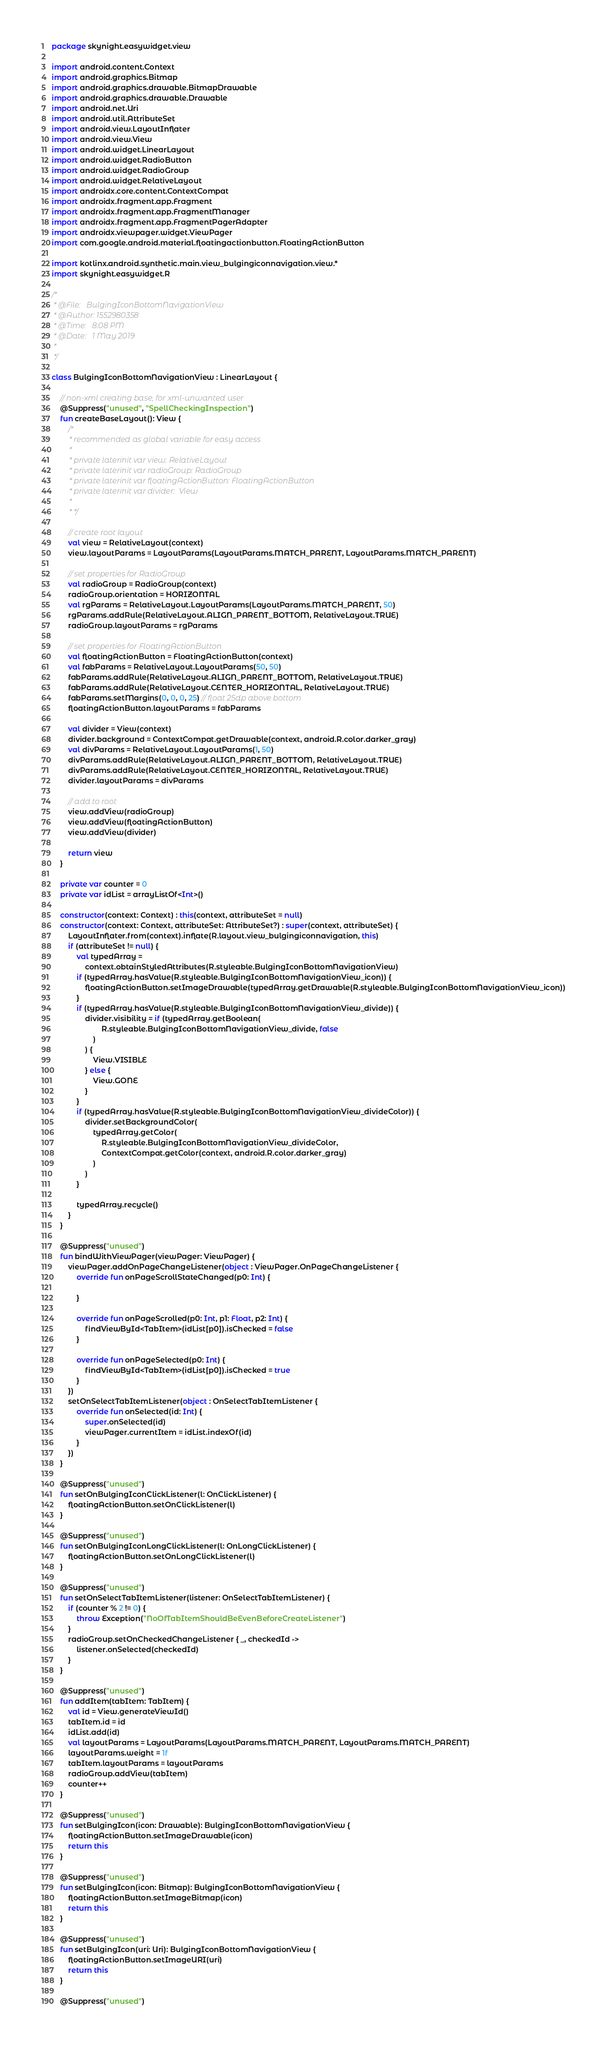Convert code to text. <code><loc_0><loc_0><loc_500><loc_500><_Kotlin_>package skynight.easywidget.view

import android.content.Context
import android.graphics.Bitmap
import android.graphics.drawable.BitmapDrawable
import android.graphics.drawable.Drawable
import android.net.Uri
import android.util.AttributeSet
import android.view.LayoutInflater
import android.view.View
import android.widget.LinearLayout
import android.widget.RadioButton
import android.widget.RadioGroup
import android.widget.RelativeLayout
import androidx.core.content.ContextCompat
import androidx.fragment.app.Fragment
import androidx.fragment.app.FragmentManager
import androidx.fragment.app.FragmentPagerAdapter
import androidx.viewpager.widget.ViewPager
import com.google.android.material.floatingactionbutton.FloatingActionButton

import kotlinx.android.synthetic.main.view_bulgingiconnavigation.view.*
import skynight.easywidget.R

/*
 * @File:   BulgingIconBottomNavigationView
 * @Author: 1552980358
 * @Time:   8:08 PM
 * @Date:   1 May 2019
 * 
 */

class BulgingIconBottomNavigationView : LinearLayout {

    // non-xml creating base, for xml-unwanted user
    @Suppress("unused", "SpellCheckingInspection")
    fun createBaseLayout(): View {
        /*
         * recommended as global variable for easy access
         *
         * private laterinit var view: RelativeLayout
         * private laterinit var radioGroup: RadioGroup
         * private laterinit var floatingActionButton: FloatingActionButton
         * private laterinit var divider:  View
         *
         * */

        // create root layout
        val view = RelativeLayout(context)
        view.layoutParams = LayoutParams(LayoutParams.MATCH_PARENT, LayoutParams.MATCH_PARENT)

        // set properties for RadioGroup
        val radioGroup = RadioGroup(context)
        radioGroup.orientation = HORIZONTAL
        val rgParams = RelativeLayout.LayoutParams(LayoutParams.MATCH_PARENT, 50)
        rgParams.addRule(RelativeLayout.ALIGN_PARENT_BOTTOM, RelativeLayout.TRUE)
        radioGroup.layoutParams = rgParams

        // set properties for FloatingActionButton
        val floatingActionButton = FloatingActionButton(context)
        val fabParams = RelativeLayout.LayoutParams(50, 50)
        fabParams.addRule(RelativeLayout.ALIGN_PARENT_BOTTOM, RelativeLayout.TRUE)
        fabParams.addRule(RelativeLayout.CENTER_HORIZONTAL, RelativeLayout.TRUE)
        fabParams.setMargins(0, 0, 0, 25) // float 25dp above bottom
        floatingActionButton.layoutParams = fabParams

        val divider = View(context)
        divider.background = ContextCompat.getDrawable(context, android.R.color.darker_gray)
        val divParams = RelativeLayout.LayoutParams(1, 50)
        divParams.addRule(RelativeLayout.ALIGN_PARENT_BOTTOM, RelativeLayout.TRUE)
        divParams.addRule(RelativeLayout.CENTER_HORIZONTAL, RelativeLayout.TRUE)
        divider.layoutParams = divParams

        // add to root
        view.addView(radioGroup)
        view.addView(floatingActionButton)
        view.addView(divider)

        return view
    }

    private var counter = 0
    private var idList = arrayListOf<Int>()

    constructor(context: Context) : this(context, attributeSet = null)
    constructor(context: Context, attributeSet: AttributeSet?) : super(context, attributeSet) {
        LayoutInflater.from(context).inflate(R.layout.view_bulgingiconnavigation, this)
        if (attributeSet != null) {
            val typedArray =
                context.obtainStyledAttributes(R.styleable.BulgingIconBottomNavigationView)
            if (typedArray.hasValue(R.styleable.BulgingIconBottomNavigationView_icon)) {
                floatingActionButton.setImageDrawable(typedArray.getDrawable(R.styleable.BulgingIconBottomNavigationView_icon))
            }
            if (typedArray.hasValue(R.styleable.BulgingIconBottomNavigationView_divide)) {
                divider.visibility = if (typedArray.getBoolean(
                        R.styleable.BulgingIconBottomNavigationView_divide, false
                    )
                ) {
                    View.VISIBLE
                } else {
                    View.GONE
                }
            }
            if (typedArray.hasValue(R.styleable.BulgingIconBottomNavigationView_divideColor)) {
                divider.setBackgroundColor(
                    typedArray.getColor(
                        R.styleable.BulgingIconBottomNavigationView_divideColor,
                        ContextCompat.getColor(context, android.R.color.darker_gray)
                    )
                )
            }

            typedArray.recycle()
        }
    }

    @Suppress("unused")
    fun bindWithViewPager(viewPager: ViewPager) {
        viewPager.addOnPageChangeListener(object : ViewPager.OnPageChangeListener {
            override fun onPageScrollStateChanged(p0: Int) {

            }

            override fun onPageScrolled(p0: Int, p1: Float, p2: Int) {
                findViewById<TabItem>(idList[p0]).isChecked = false
            }

            override fun onPageSelected(p0: Int) {
                findViewById<TabItem>(idList[p0]).isChecked = true
            }
        })
        setOnSelectTabItemListener(object : OnSelectTabItemListener {
            override fun onSelected(id: Int) {
                super.onSelected(id)
                viewPager.currentItem = idList.indexOf(id)
            }
        })
    }

    @Suppress("unused")
    fun setOnBulgingIconClickListener(l: OnClickListener) {
        floatingActionButton.setOnClickListener(l)
    }

    @Suppress("unused")
    fun setOnBulgingIconLongClickListener(l: OnLongClickListener) {
        floatingActionButton.setOnLongClickListener(l)
    }

    @Suppress("unused")
    fun setOnSelectTabItemListener(listener: OnSelectTabItemListener) {
        if (counter % 2 != 0) {
            throw Exception("NoOfTabItemShouldBeEvenBeforeCreateListener")
        }
        radioGroup.setOnCheckedChangeListener { _, checkedId ->
            listener.onSelected(checkedId)
        }
    }

    @Suppress("unused")
    fun addItem(tabItem: TabItem) {
        val id = View.generateViewId()
        tabItem.id = id
        idList.add(id)
        val layoutParams = LayoutParams(LayoutParams.MATCH_PARENT, LayoutParams.MATCH_PARENT)
        layoutParams.weight = 1f
        tabItem.layoutParams = layoutParams
        radioGroup.addView(tabItem)
        counter++
    }

    @Suppress("unused")
    fun setBulgingIcon(icon: Drawable): BulgingIconBottomNavigationView {
        floatingActionButton.setImageDrawable(icon)
        return this
    }

    @Suppress("unused")
    fun setBulgingIcon(icon: Bitmap): BulgingIconBottomNavigationView {
        floatingActionButton.setImageBitmap(icon)
        return this
    }

    @Suppress("unused")
    fun setBulgingIcon(uri: Uri): BulgingIconBottomNavigationView {
        floatingActionButton.setImageURI(uri)
        return this
    }

    @Suppress("unused")</code> 